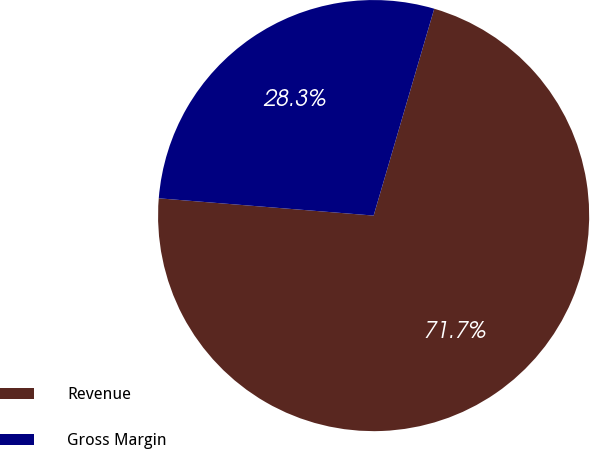Convert chart. <chart><loc_0><loc_0><loc_500><loc_500><pie_chart><fcel>Revenue<fcel>Gross Margin<nl><fcel>71.74%<fcel>28.26%<nl></chart> 